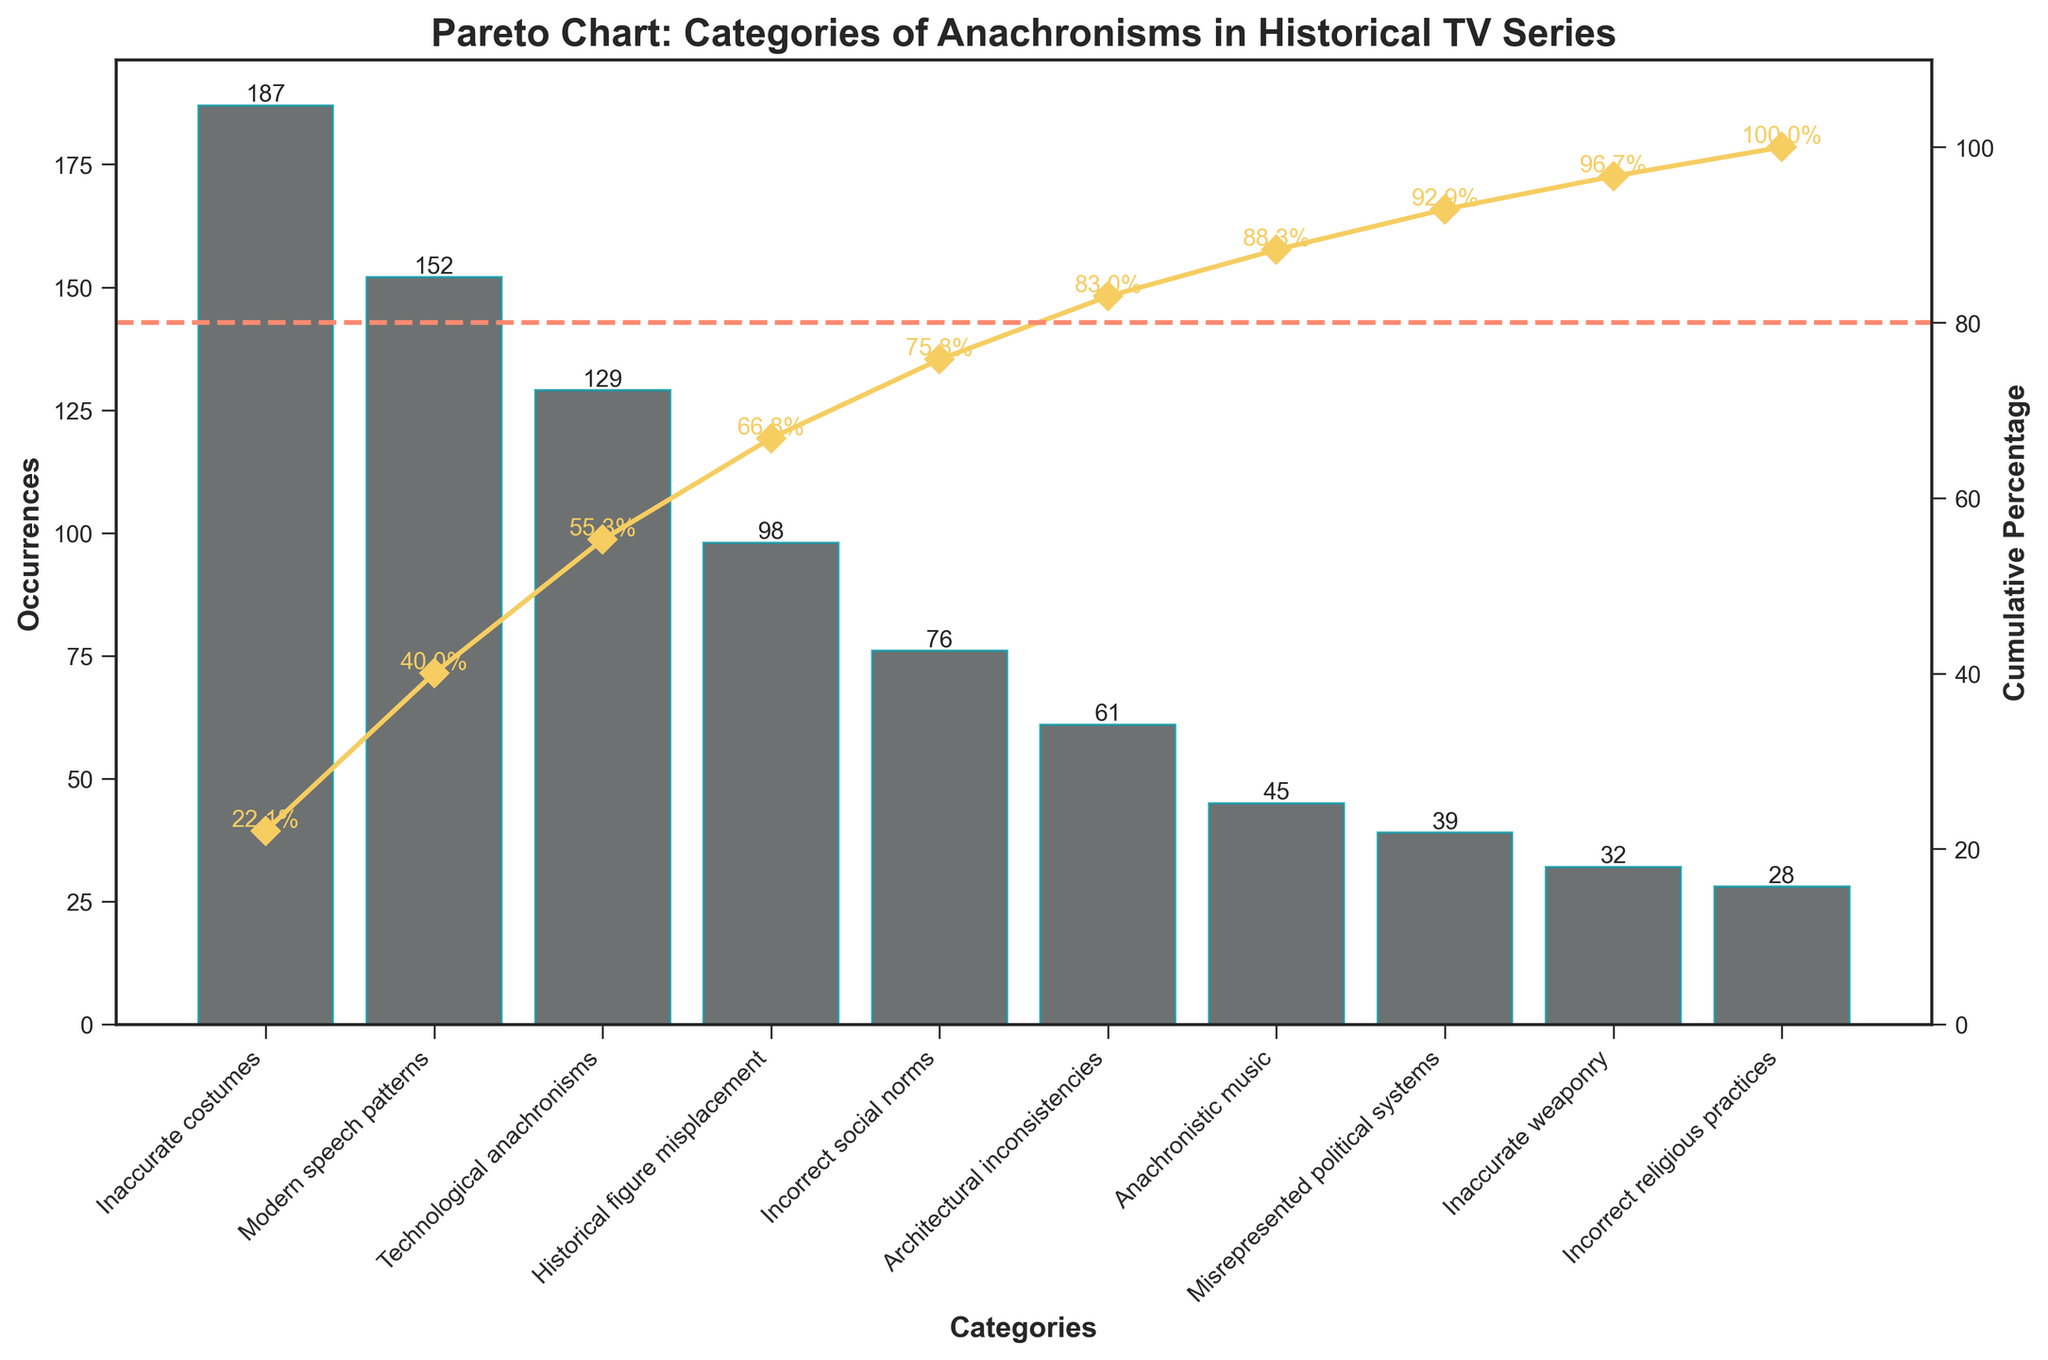What is the title of the chart? The title of the chart is usually located at the top center of the figure and provides a quick summary of the content. Here, the title reads "Pareto Chart: Categories of Anachronisms in Historical TV Series".
Answer: Pareto Chart: Categories of Anachronisms in Historical TV Series How many anachronism categories are listed in the chart? To find the number of categories, look at the x-axis, which lists the distinct categories of anachronisms. Count each category listed.
Answer: 10 What category has the highest number of occurrences and how many times does it occur? The category with the highest number of occurrences can be found by looking at the tallest bar in the bar plot. The tallest bar corresponds to "Inaccurate costumes" with 187 occurrences.
Answer: Inaccurate costumes, 187 Which category has the lowest number of occurrences, and what is the cumulative percentage at that point? The smallest bar on the chart represents the category with the fewest occurrences. The cumulative percentage associated with that category can be found on the secondary y-axis at the same x-axis position. Here, "Incorrect religious practices" has the lowest occurrences (28), and the cumulative percentage at that point is 100%.
Answer: Incorrect religious practices, 100% What is the cumulative percentage after the top three categories of anachronisms? Sum the occurrences of the top three categories and then find the corresponding cumulative percentage from the secondary y-axis. The top three categories are "Inaccurate costumes" (187), "Modern speech patterns" (152), and "Technological anachronisms" (129). The cumulative percentage after summing these numbers is approximately 66.0%.
Answer: 66.0% How does the occurrence of "Modern speech patterns" compare to "Incorrect social norms"? Compare the height of the bars for "Modern speech patterns" and "Incorrect social norms". "Modern speech patterns" has 152 occurrences, while "Incorrect social norms" has 76 occurrences. Modern speech patterns occur twice as often as incorrect social norms.
Answer: Modern speech patterns occur twice as often as incorrect social norms Which category surpasses the 80% cumulative percentage line? Look at the cumulative percentage line plotted across and identify the category at the point where the cumulative percentage line crosses 80%. The "Incorrect social norms" category surpasses the 80% cumulative percentage.
Answer: Incorrect social norms What is the cumulative percentage after adding the occurrences of the first five categories? Add the occurrences of the first five categories: "Inaccurate costumes" (187), "Modern speech patterns" (152), "Technological anachronisms" (129), "Historical figure misplacement" (98), and "Incorrect social norms" (76). The cumulative percentage can then be read off the secondary y-axis, which is approximately 87.3%.
Answer: 87.3% How many categories have more than 50 occurrences? Count the number of bars that extend above the 50 occurrences mark on the primary y-axis. There are 6 such categories: "Inaccurate costumes", "Modern speech patterns", "Technological anachronisms", "Historical figure misplacement", "Incorrect social norms", and "Architectural inconsistencies".
Answer: 6 